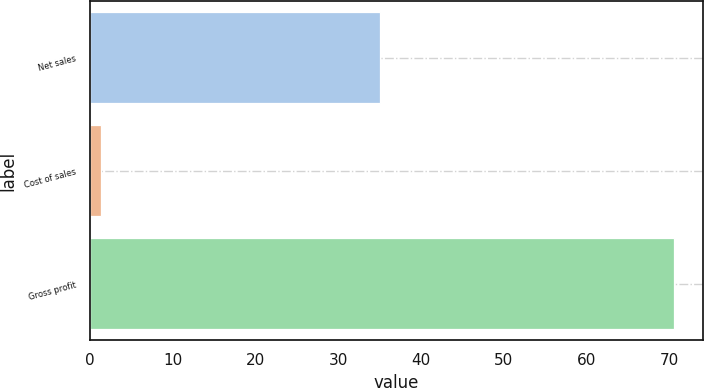<chart> <loc_0><loc_0><loc_500><loc_500><bar_chart><fcel>Net sales<fcel>Cost of sales<fcel>Gross profit<nl><fcel>35.1<fcel>1.3<fcel>70.6<nl></chart> 